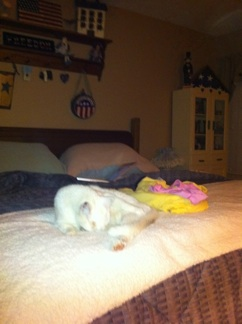What do you think is the cat's favorite activity in this room? The cat likely enjoys lounging on the soft bed, soaking up the comfort and warmth. It might also play with the colorful toy next to it, which adds an element of fun to its cozy spot. How does the room contribute to the cat's comfort? The room contributes significantly to the cat’s comfort. The soft bedding provides a warm and cushy place for it to relax. The ample decor and cozy arrangement make the space feel safe and homely, which is likely important for the cat's sense of security and well-being. 